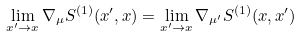<formula> <loc_0><loc_0><loc_500><loc_500>\lim _ { x ^ { \prime } \rightarrow { x } } \nabla _ { \mu } { S ^ { ( 1 ) } ( x ^ { \prime } , x ) } = \lim _ { x ^ { \prime } \rightarrow { x } } \nabla _ { \mu ^ { \prime } } { S ^ { ( 1 ) } ( x , x ^ { \prime } ) }</formula> 